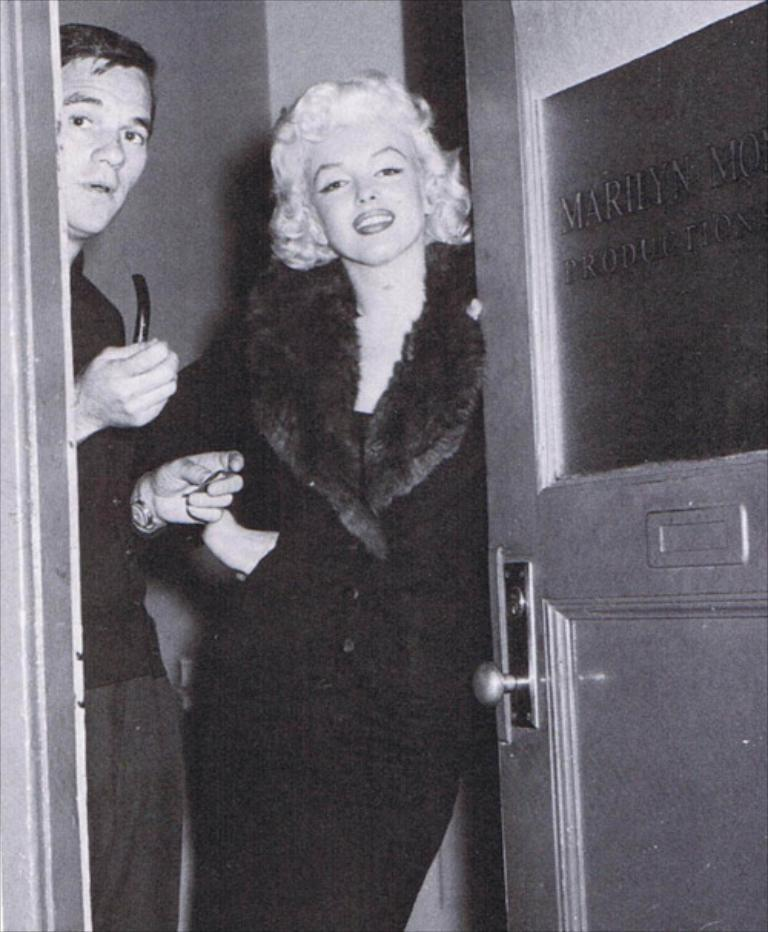How many people are present in the image? There are two people standing in the image. What can be seen on the right side of the image? There is a door on the right side of the image. What is written information is present on the door? There is text on the door. What is visible in the background of the image? There is a wall in the background of the image. What type of volleyball game is being played in the image? There is no volleyball game present in the image. Can you describe the veins visible in the image? There are no veins visible in the image. 